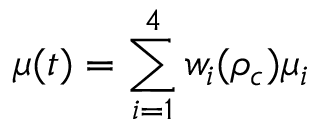<formula> <loc_0><loc_0><loc_500><loc_500>\mu ( t ) = \sum _ { i = 1 } ^ { 4 } w _ { i } ( \rho _ { c } ) \mu _ { i }</formula> 